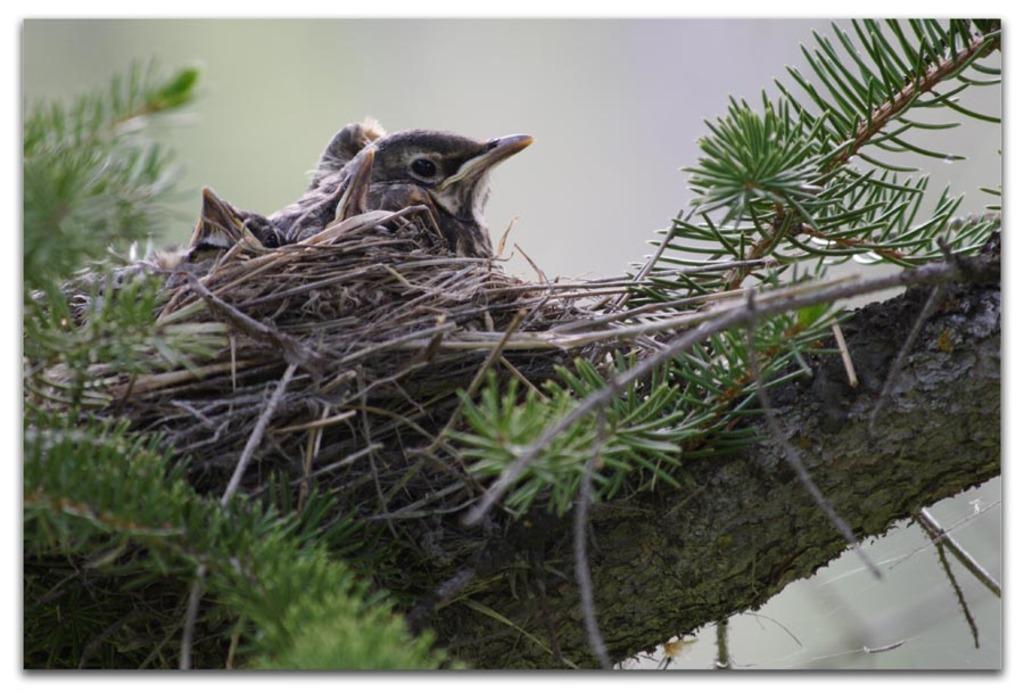Describe this image in one or two sentences. In this picture we can see a nest on the tree and we can find a bird in the nest. 